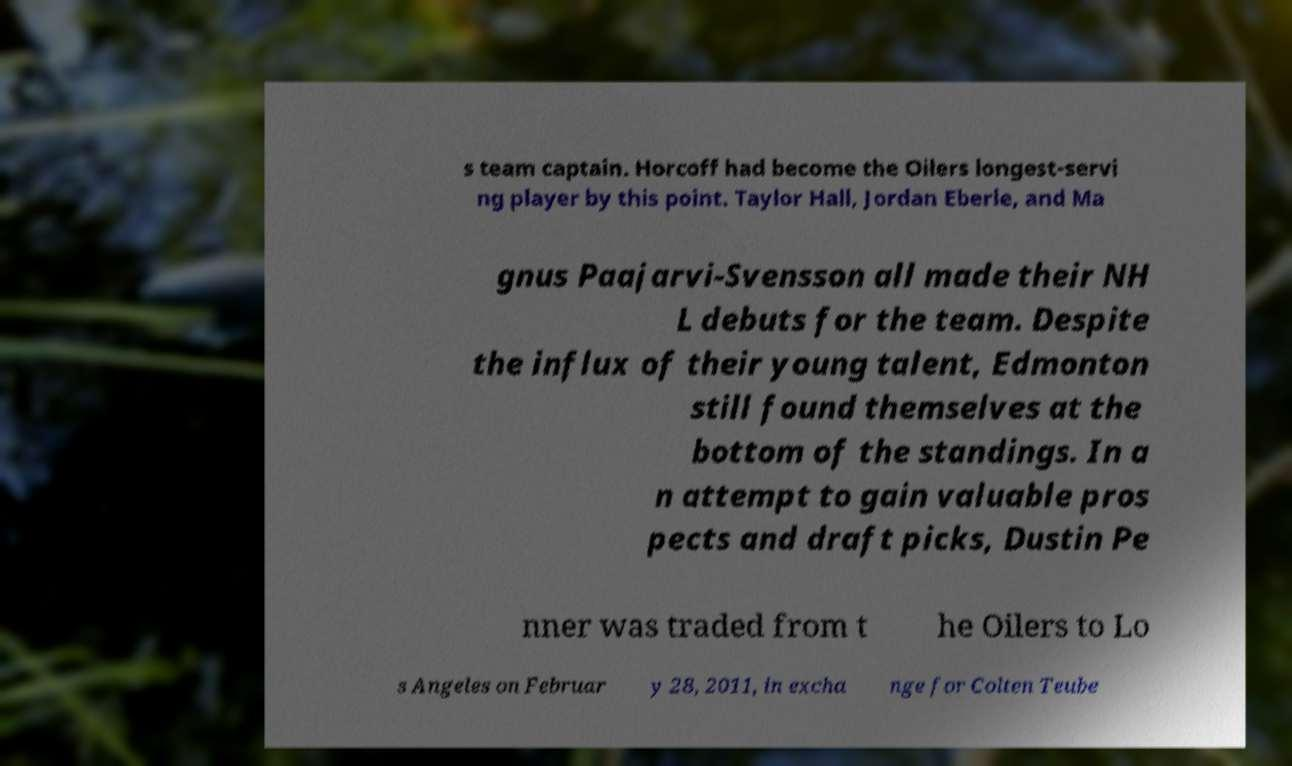There's text embedded in this image that I need extracted. Can you transcribe it verbatim? s team captain. Horcoff had become the Oilers longest-servi ng player by this point. Taylor Hall, Jordan Eberle, and Ma gnus Paajarvi-Svensson all made their NH L debuts for the team. Despite the influx of their young talent, Edmonton still found themselves at the bottom of the standings. In a n attempt to gain valuable pros pects and draft picks, Dustin Pe nner was traded from t he Oilers to Lo s Angeles on Februar y 28, 2011, in excha nge for Colten Teube 